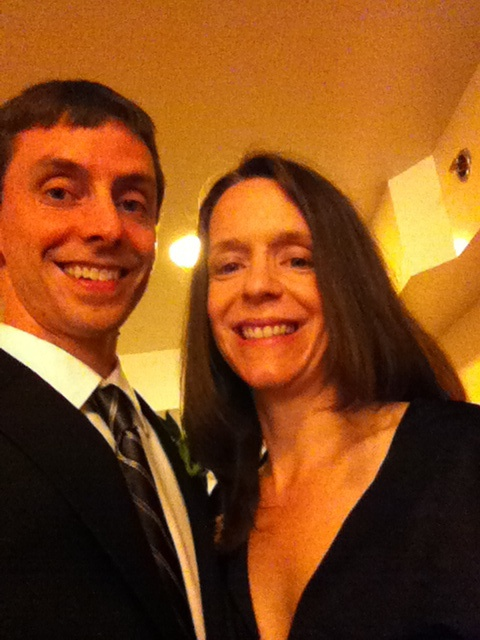Describe the objects in this image and their specific colors. I can see people in red, black, maroon, and orange tones, people in red, black, maroon, and brown tones, and tie in red, black, maroon, and gray tones in this image. 